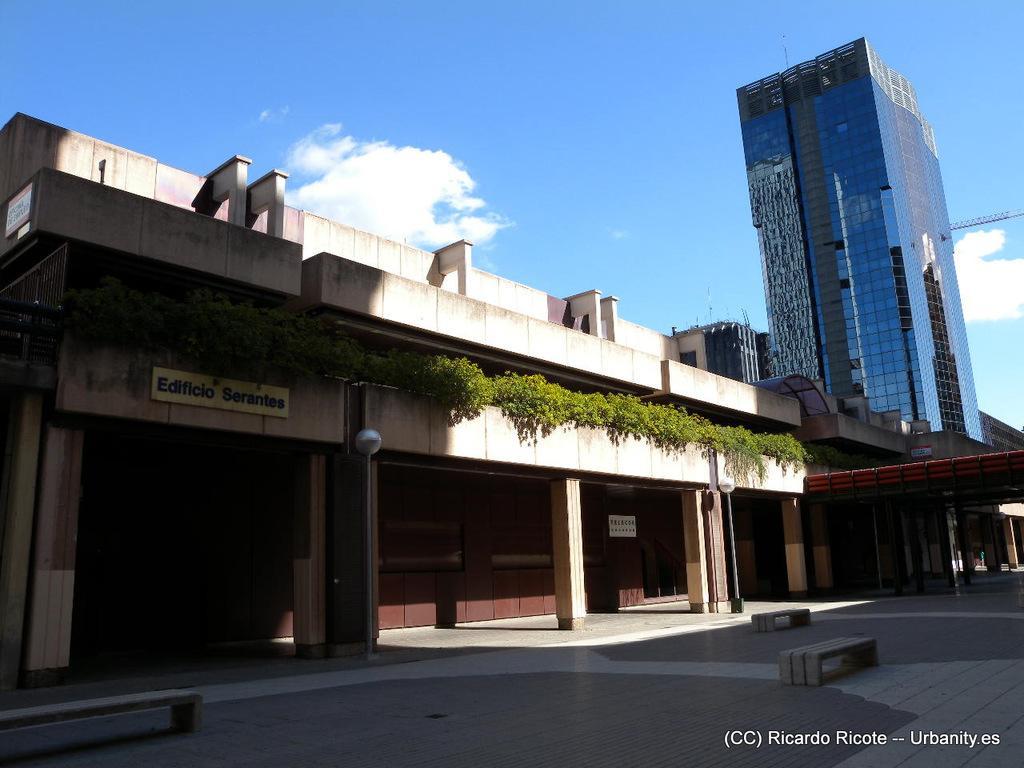Could you give a brief overview of what you see in this image? In this image there are some houses and buildings, at the bottom there is a floor, and in the center there are some plants and one board. On the top of the image there is sky. 